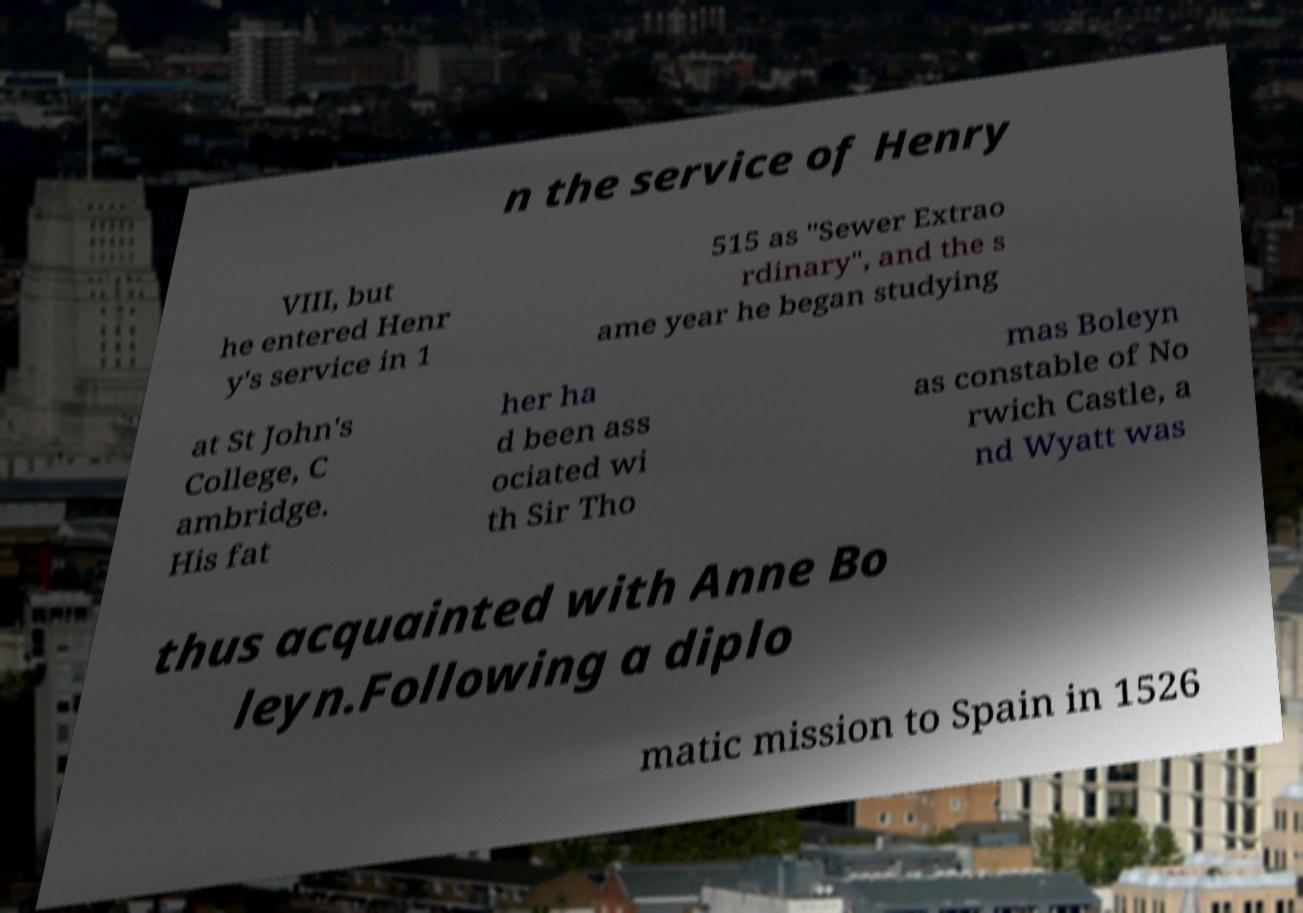I need the written content from this picture converted into text. Can you do that? n the service of Henry VIII, but he entered Henr y's service in 1 515 as "Sewer Extrao rdinary", and the s ame year he began studying at St John's College, C ambridge. His fat her ha d been ass ociated wi th Sir Tho mas Boleyn as constable of No rwich Castle, a nd Wyatt was thus acquainted with Anne Bo leyn.Following a diplo matic mission to Spain in 1526 